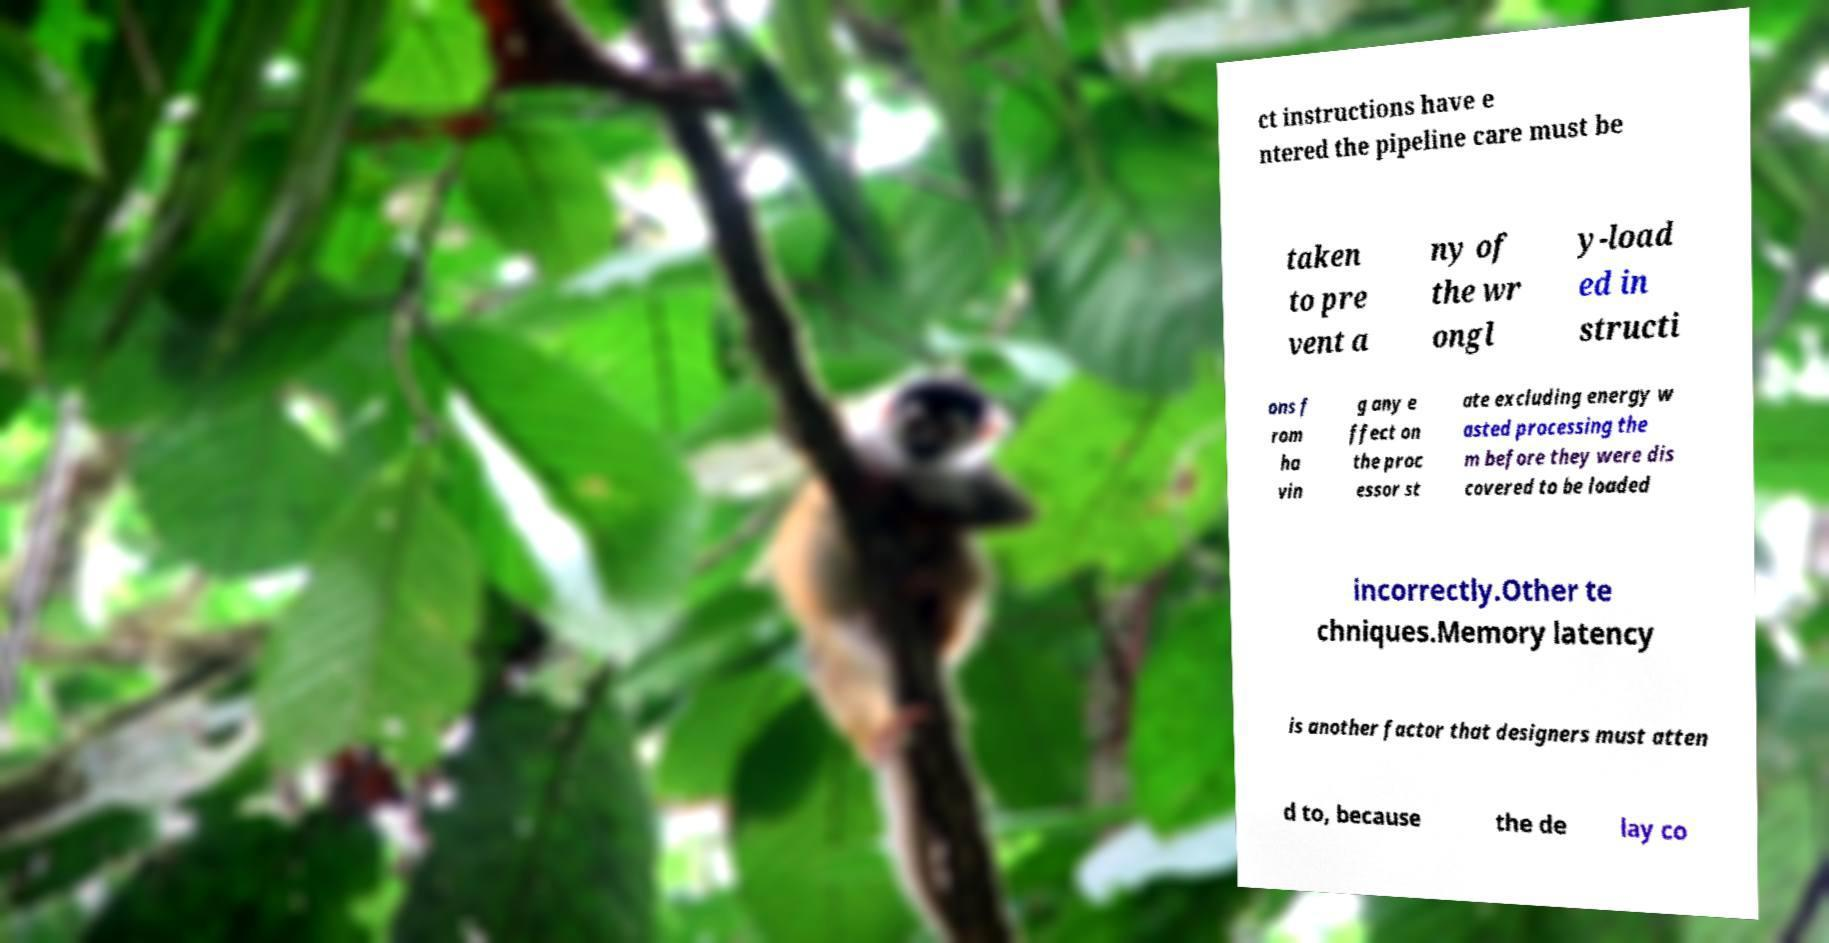I need the written content from this picture converted into text. Can you do that? ct instructions have e ntered the pipeline care must be taken to pre vent a ny of the wr ongl y-load ed in structi ons f rom ha vin g any e ffect on the proc essor st ate excluding energy w asted processing the m before they were dis covered to be loaded incorrectly.Other te chniques.Memory latency is another factor that designers must atten d to, because the de lay co 